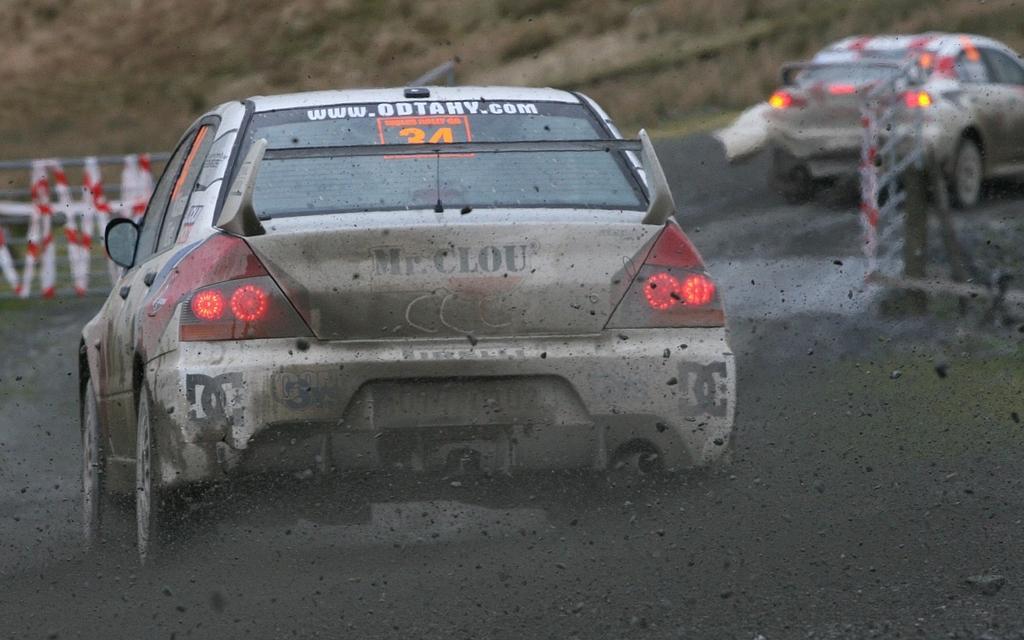Can you describe this image briefly? In this picture I can see there is a car moving and there is another car here on to the right side. There is black soil here on the floor and there is a mountain in the backdrop. 